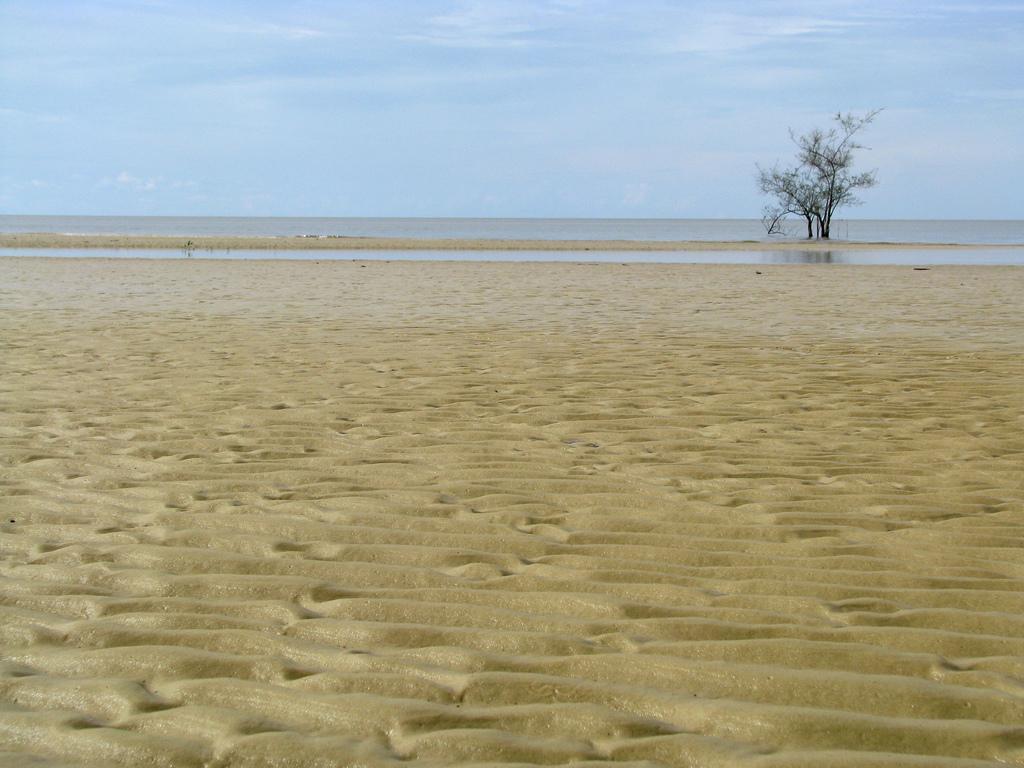Describe this image in one or two sentences. In this image we can see vast sandy land. Background of the image one tree and water is there. At the top of the image sky is present with cloud. 